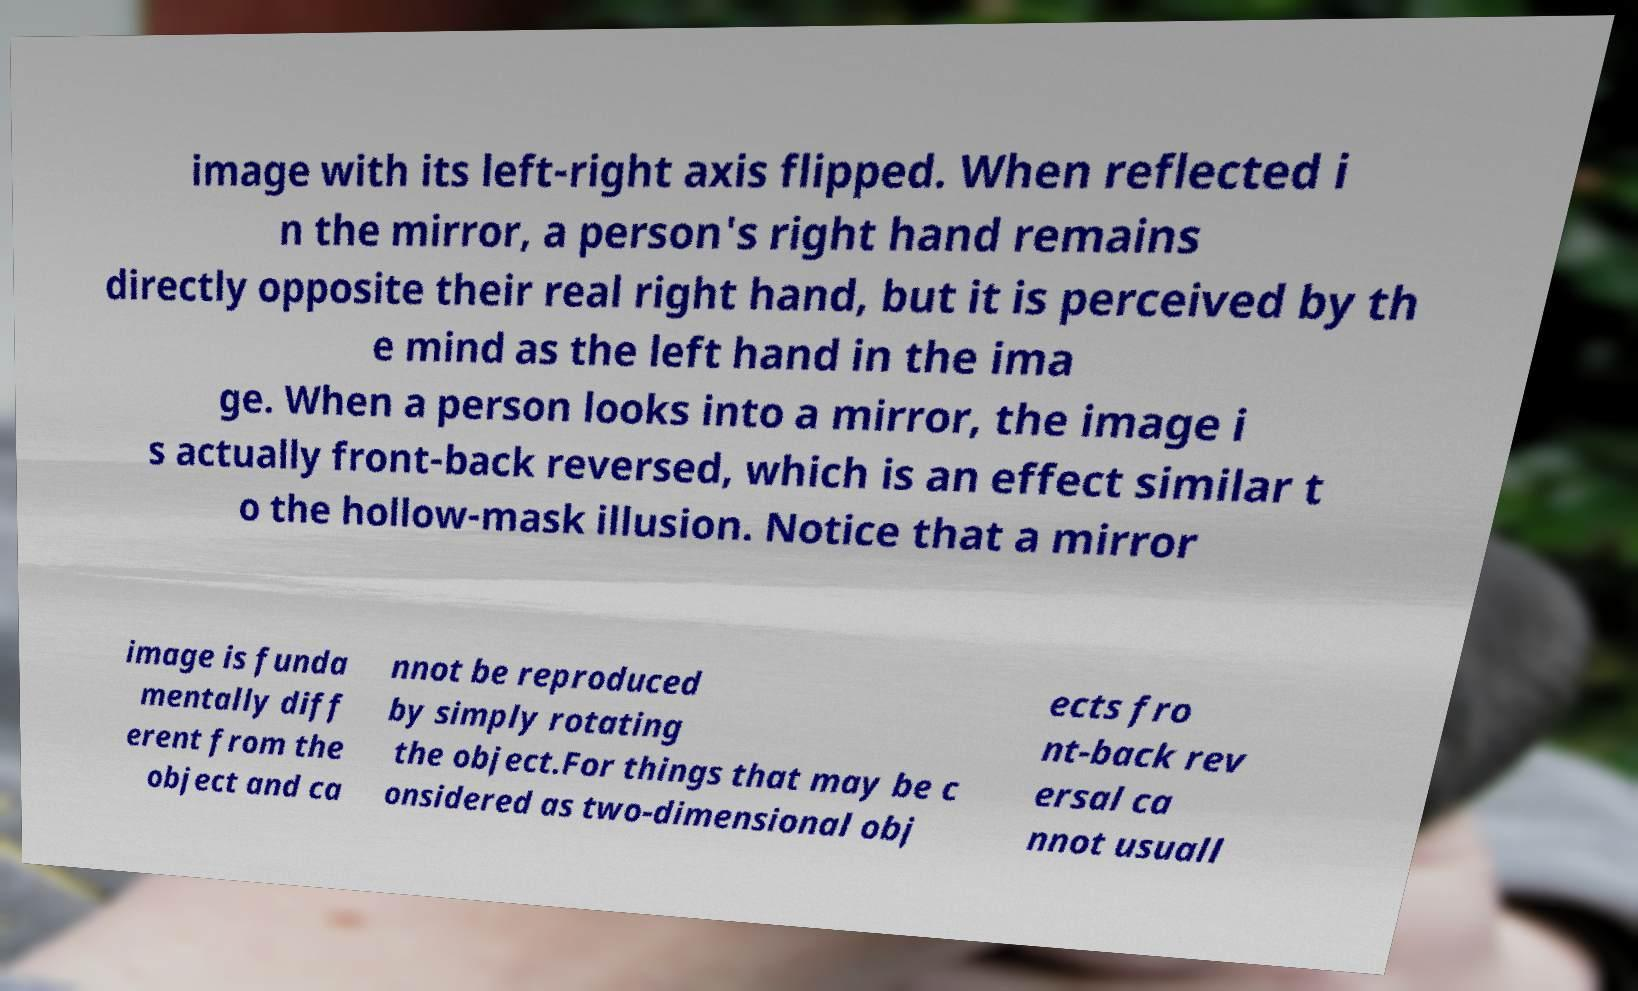Please identify and transcribe the text found in this image. image with its left-right axis flipped. When reflected i n the mirror, a person's right hand remains directly opposite their real right hand, but it is perceived by th e mind as the left hand in the ima ge. When a person looks into a mirror, the image i s actually front-back reversed, which is an effect similar t o the hollow-mask illusion. Notice that a mirror image is funda mentally diff erent from the object and ca nnot be reproduced by simply rotating the object.For things that may be c onsidered as two-dimensional obj ects fro nt-back rev ersal ca nnot usuall 